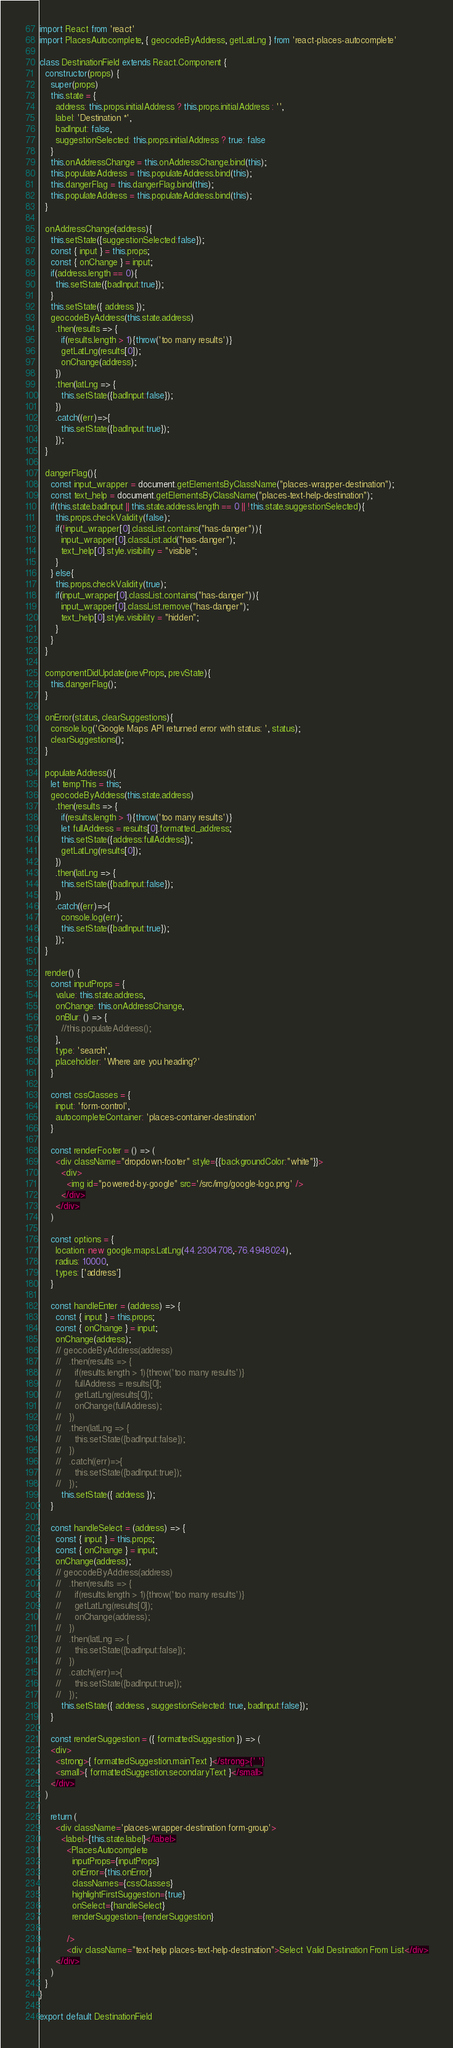Convert code to text. <code><loc_0><loc_0><loc_500><loc_500><_JavaScript_>import React from 'react'
import PlacesAutocomplete, { geocodeByAddress, getLatLng } from 'react-places-autocomplete'

class DestinationField extends React.Component {
  constructor(props) {
    super(props)
    this.state = {
      address: this.props.initialAddress ? this.props.initialAddress : '',
      label: 'Destination *',
      badInput: false,
      suggestionSelected: this.props.initialAddress ? true: false
    }
    this.onAddressChange = this.onAddressChange.bind(this);
    this.populateAddress = this.populateAddress.bind(this);
    this.dangerFlag = this.dangerFlag.bind(this);
    this.populateAddress = this.populateAddress.bind(this);
  }

  onAddressChange(address){
    this.setState({suggestionSelected:false});
    const { input } = this.props;
    const { onChange } = input;
    if(address.length == 0){
      this.setState({badInput:true});
    }
    this.setState({ address });
    geocodeByAddress(this.state.address)
      .then(results => {
        if(results.length > 1){throw('too many results')}
        getLatLng(results[0]);
        onChange(address);
      })
      .then(latLng => {
        this.setState({badInput:false});
      })
      .catch((err)=>{
        this.setState({badInput:true});
      });
  }

  dangerFlag(){
    const input_wrapper = document.getElementsByClassName("places-wrapper-destination");
    const text_help = document.getElementsByClassName("places-text-help-destination");
    if(this.state.badInput || this.state.address.length == 0 || !this.state.suggestionSelected){
      this.props.checkValidity(false);
      if(!input_wrapper[0].classList.contains("has-danger")){
        input_wrapper[0].classList.add("has-danger");
        text_help[0].style.visibility = "visible";
      }
    } else{
      this.props.checkValidity(true);
      if(input_wrapper[0].classList.contains("has-danger")){
        input_wrapper[0].classList.remove("has-danger");
        text_help[0].style.visibility = "hidden";
      }
    }
  }

  componentDidUpdate(prevProps, prevState){
    this.dangerFlag();
  }

  onError(status, clearSuggestions){
    console.log('Google Maps API returned error with status: ', status);
    clearSuggestions();
  }

  populateAddress(){
    let tempThis = this;
    geocodeByAddress(this.state.address)
      .then(results => {
        if(results.length > 1){throw('too many results')}
        let fullAddress = results[0].formatted_address;
        this.setState({address:fullAddress});
        getLatLng(results[0]);
      })
      .then(latLng => {
        this.setState({badInput:false});
      })
      .catch((err)=>{
        console.log(err);
        this.setState({badInput:true});
      });
  }

  render() {
    const inputProps = {
      value: this.state.address,
      onChange: this.onAddressChange,
      onBlur: () => {
        //this.populateAddress();
      },
      type: 'search',
      placeholder: 'Where are you heading?'
    }

    const cssClasses = {
      input: 'form-control',
      autocompleteContainer: 'places-container-destination'
    }

    const renderFooter = () => (
      <div className="dropdown-footer" style={{backgroundColor:"white"}}>
        <div>
          <img id="powered-by-google" src='/src/img/google-logo.png' />
        </div>
      </div>
    )

    const options = {
      location: new google.maps.LatLng(44.2304708,-76.4948024),
      radius: 10000,
      types: ['address']
    }

    const handleEnter = (address) => {
      const { input } = this.props;
      const { onChange } = input;
      onChange(address);
      // geocodeByAddress(address)
      //   .then(results => {
      //     if(results.length > 1){throw('too many results')}
      //     fullAddress = results[0];
      //     getLatLng(results[0]);
      //     onChange(fullAddress);
      //   })
      //   .then(latLng => {
      //     this.setState({badInput:false});
      //   })
      //   .catch((err)=>{
      //     this.setState({badInput:true});
      //   });
        this.setState({ address });
    }

    const handleSelect = (address) => {
      const { input } = this.props;
      const { onChange } = input;
      onChange(address);
      // geocodeByAddress(address)
      //   .then(results => {
      //     if(results.length > 1){throw('too many results')}
      //     getLatLng(results[0]);
      //     onChange(address);
      //   })
      //   .then(latLng => {
      //     this.setState({badInput:false});
      //   })
      //   .catch((err)=>{
      //     this.setState({badInput:true});
      //   });
        this.setState({ address , suggestionSelected: true, badInput:false});
    }

    const renderSuggestion = ({ formattedSuggestion }) => (
    <div>
      <strong>{ formattedSuggestion.mainText }</strong>{' '}
      <small>{ formattedSuggestion.secondaryText }</small>
    </div>
  )

    return (
      <div className='places-wrapper-destination form-group'>
        <label>{this.state.label}</label>
          <PlacesAutocomplete
            inputProps={inputProps}
            onError={this.onError}
            classNames={cssClasses}
            highlightFirstSuggestion={true}
            onSelect={handleSelect}
            renderSuggestion={renderSuggestion}

          />
          <div className="text-help places-text-help-destination">Select Valid Destination From List</div>
      </div>
    )
  }
}

export default DestinationField
</code> 